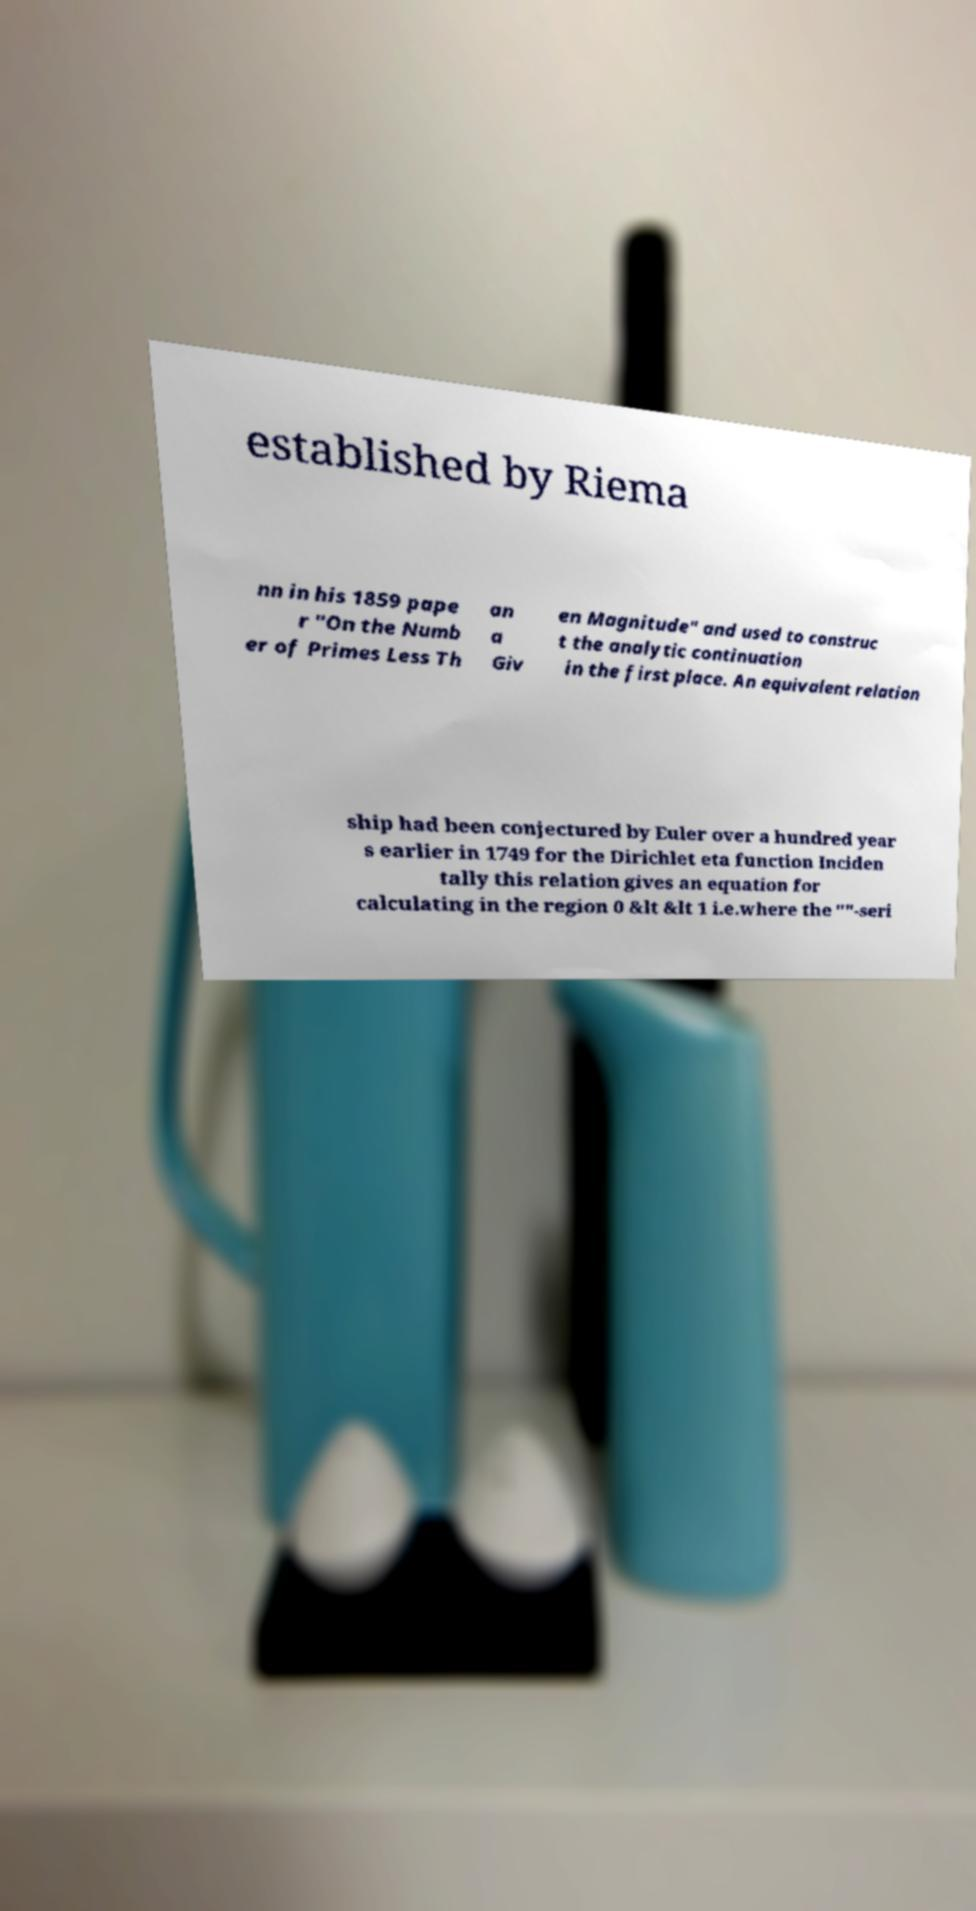Can you read and provide the text displayed in the image?This photo seems to have some interesting text. Can you extract and type it out for me? established by Riema nn in his 1859 pape r "On the Numb er of Primes Less Th an a Giv en Magnitude" and used to construc t the analytic continuation in the first place. An equivalent relation ship had been conjectured by Euler over a hundred year s earlier in 1749 for the Dirichlet eta function Inciden tally this relation gives an equation for calculating in the region 0 &lt &lt 1 i.e.where the ""-seri 